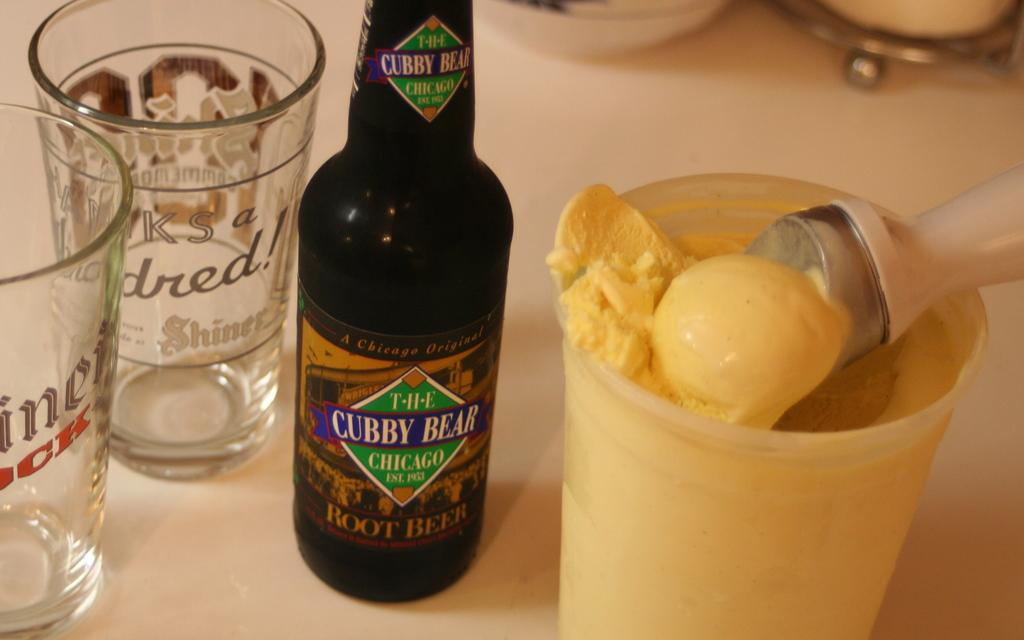<image>
Create a compact narrative representing the image presented. A bottle of Root Beer and two pint glasses sit next to a tub of vanilla ice cream. 